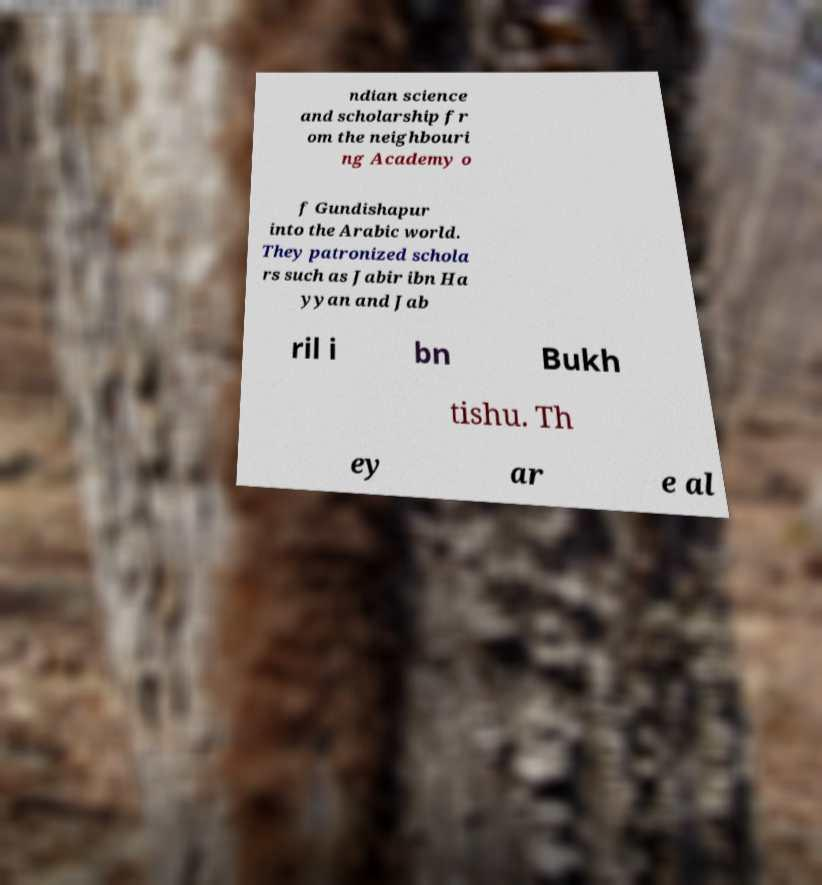What messages or text are displayed in this image? I need them in a readable, typed format. ndian science and scholarship fr om the neighbouri ng Academy o f Gundishapur into the Arabic world. They patronized schola rs such as Jabir ibn Ha yyan and Jab ril i bn Bukh tishu. Th ey ar e al 